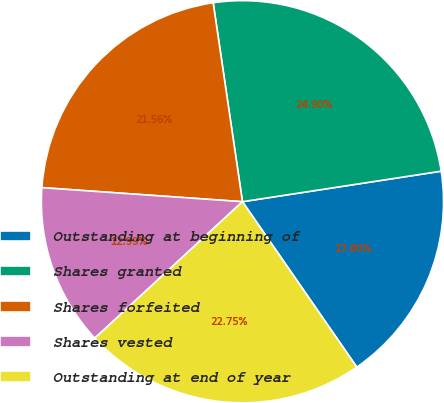Convert chart to OTSL. <chart><loc_0><loc_0><loc_500><loc_500><pie_chart><fcel>Outstanding at beginning of<fcel>Shares granted<fcel>Shares forfeited<fcel>Shares vested<fcel>Outstanding at end of year<nl><fcel>17.8%<fcel>24.9%<fcel>21.56%<fcel>12.99%<fcel>22.75%<nl></chart> 